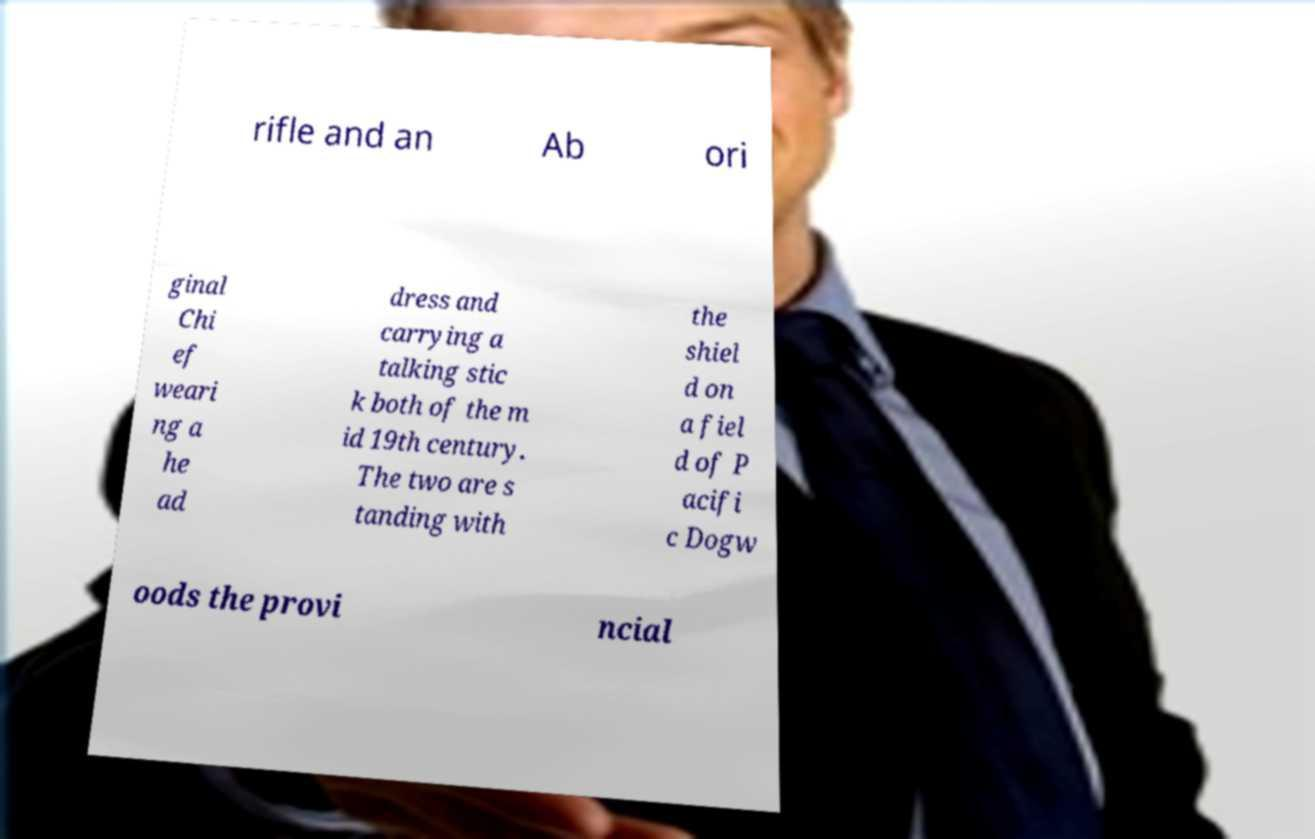I need the written content from this picture converted into text. Can you do that? rifle and an Ab ori ginal Chi ef weari ng a he ad dress and carrying a talking stic k both of the m id 19th century. The two are s tanding with the shiel d on a fiel d of P acifi c Dogw oods the provi ncial 